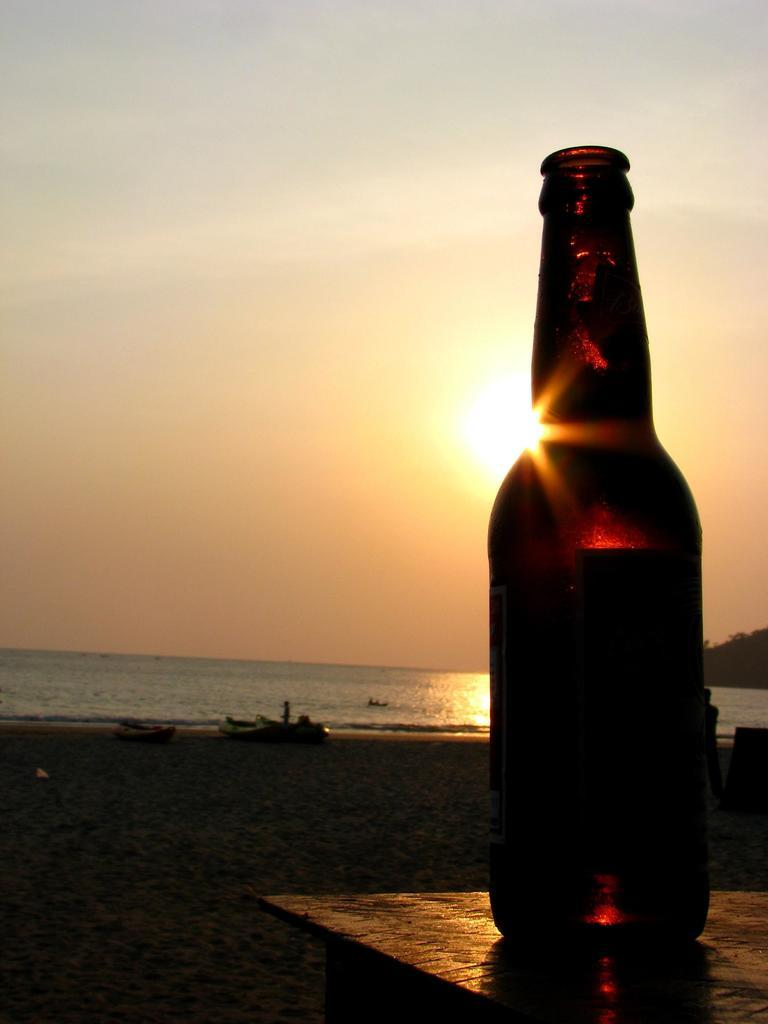What is on the table in the image? There is a wine bottle on a table in the image. What can be seen in the sky in the image? The sky is visible in the image, and clouds and the sun are present. What is the body of water in the image? There is water visible in the image, and a boat is present. What type of terrain is present in the image? Sand is present in the image. How much wealth is displayed in the garden in the image? There is no garden present in the image, and no information about wealth is provided. 